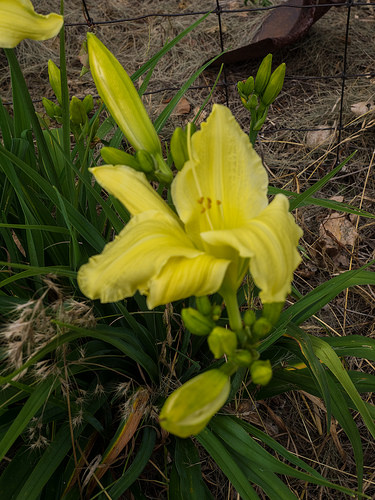<image>
Is the flower on the fence? No. The flower is not positioned on the fence. They may be near each other, but the flower is not supported by or resting on top of the fence. 